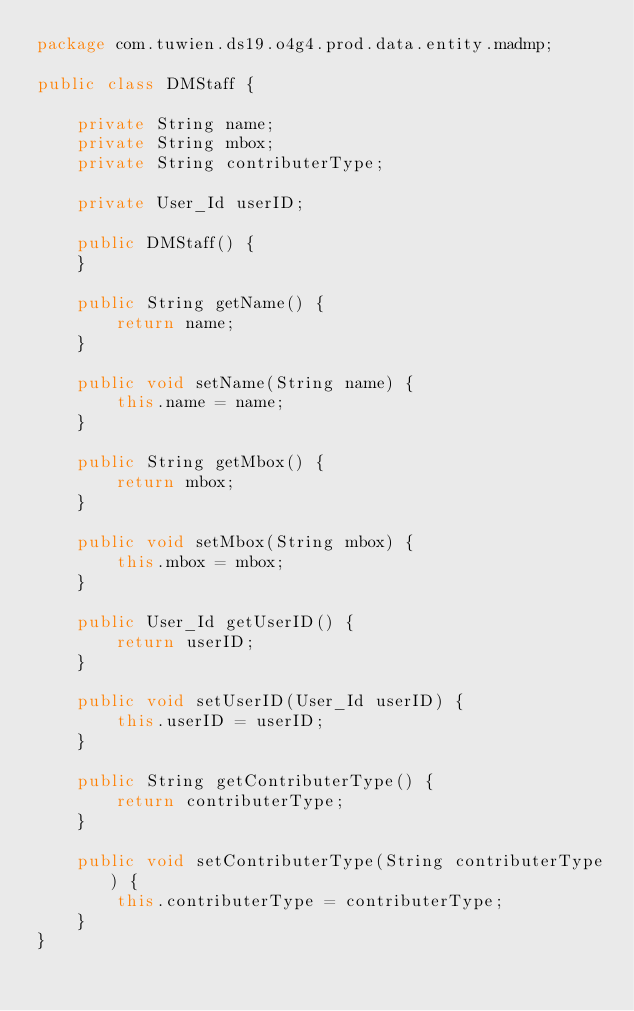<code> <loc_0><loc_0><loc_500><loc_500><_Java_>package com.tuwien.ds19.o4g4.prod.data.entity.madmp;

public class DMStaff {

    private String name;
    private String mbox;
    private String contributerType;

    private User_Id userID;

    public DMStaff() {
    }

    public String getName() {
        return name;
    }

    public void setName(String name) {
        this.name = name;
    }

    public String getMbox() {
        return mbox;
    }

    public void setMbox(String mbox) {
        this.mbox = mbox;
    }

    public User_Id getUserID() {
        return userID;
    }

    public void setUserID(User_Id userID) {
        this.userID = userID;
    }

    public String getContributerType() {
        return contributerType;
    }

    public void setContributerType(String contributerType) {
        this.contributerType = contributerType;
    }
}
</code> 